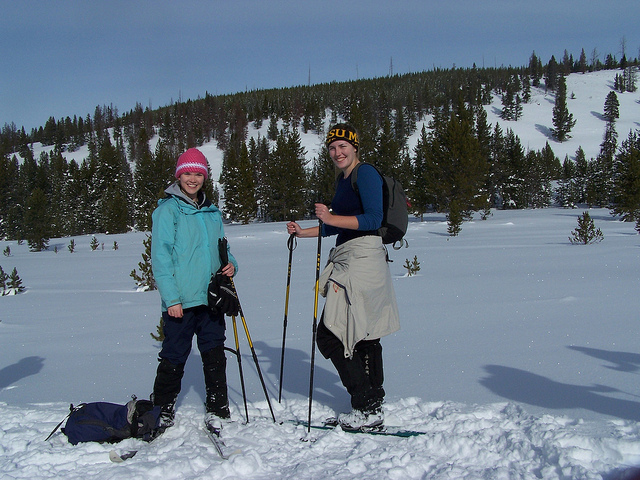Please identify all text content in this image. SU M 